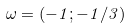Convert formula to latex. <formula><loc_0><loc_0><loc_500><loc_500>\omega = ( - 1 ; - 1 / 3 )</formula> 